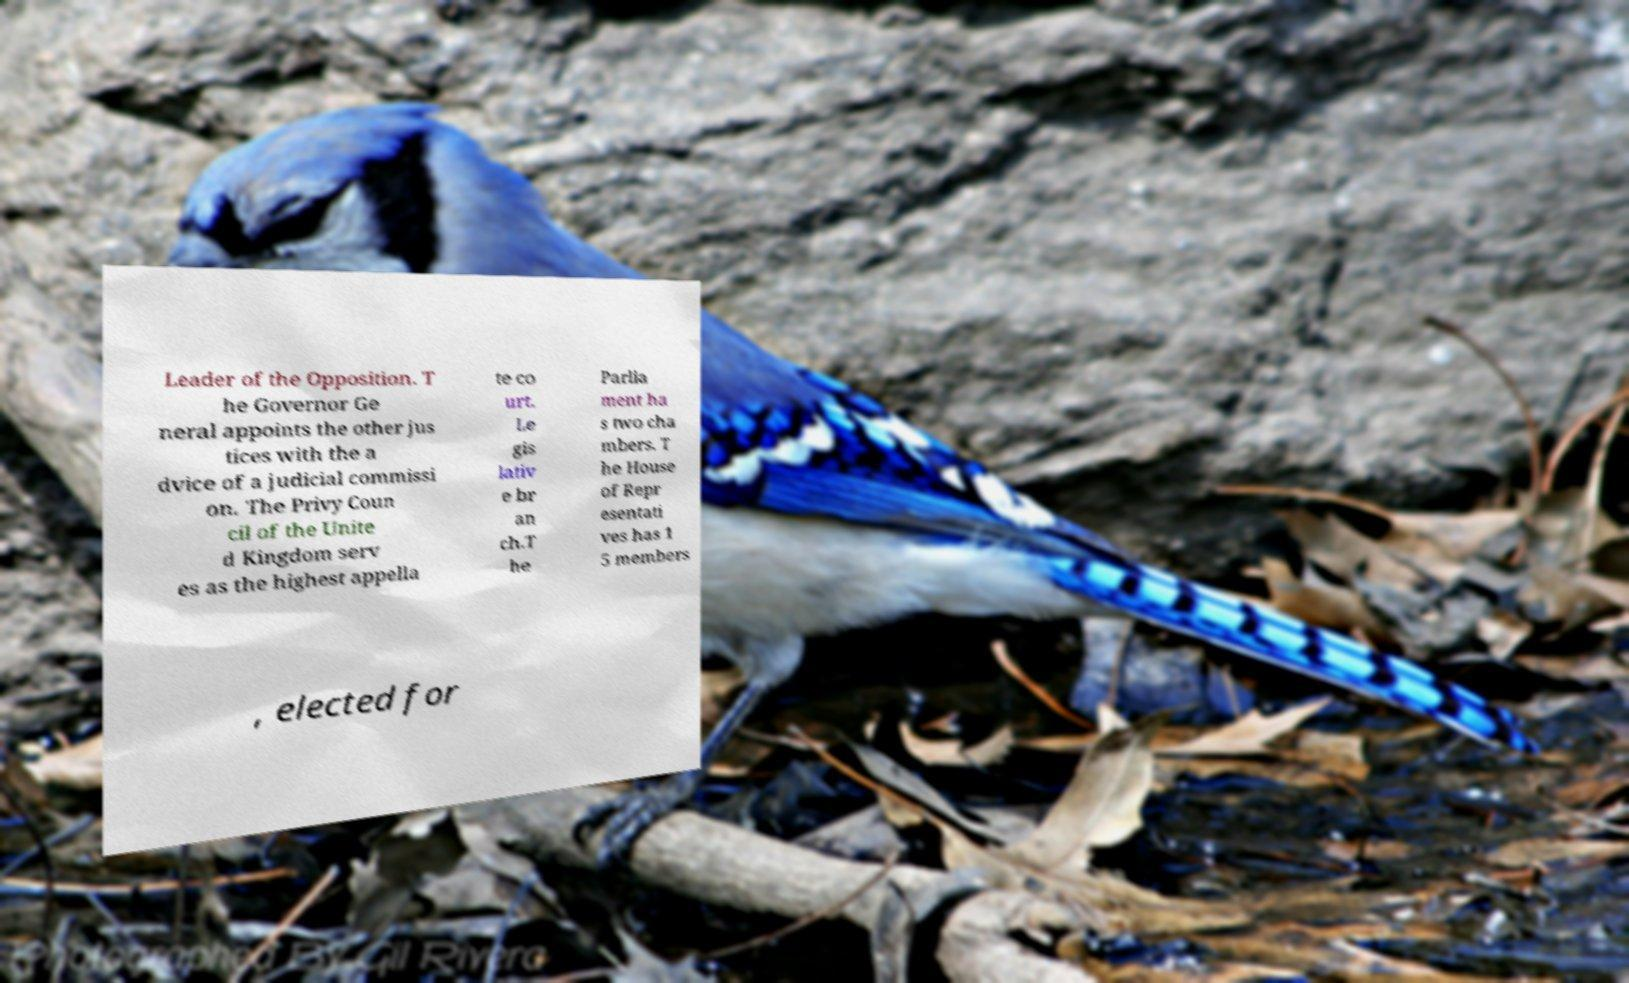For documentation purposes, I need the text within this image transcribed. Could you provide that? Leader of the Opposition. T he Governor Ge neral appoints the other jus tices with the a dvice of a judicial commissi on. The Privy Coun cil of the Unite d Kingdom serv es as the highest appella te co urt. Le gis lativ e br an ch.T he Parlia ment ha s two cha mbers. T he House of Repr esentati ves has 1 5 members , elected for 